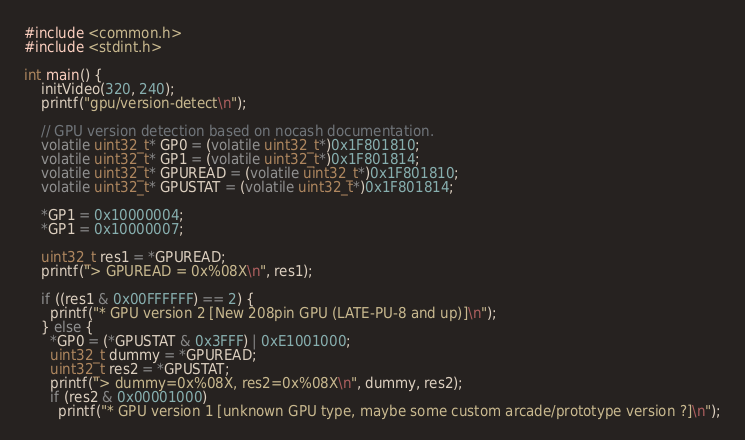<code> <loc_0><loc_0><loc_500><loc_500><_C++_>#include <common.h>
#include <stdint.h>

int main() {
    initVideo(320, 240);
    printf("gpu/version-detect\n");

    // GPU version detection based on nocash documentation.
    volatile uint32_t* GP0 = (volatile uint32_t*)0x1F801810;
    volatile uint32_t* GP1 = (volatile uint32_t*)0x1F801814;
    volatile uint32_t* GPUREAD = (volatile uint32_t*)0x1F801810;
    volatile uint32_t* GPUSTAT = (volatile uint32_t*)0x1F801814;

    *GP1 = 0x10000004;
    *GP1 = 0x10000007;

    uint32_t res1 = *GPUREAD;
    printf("> GPUREAD = 0x%08X\n", res1);

    if ((res1 & 0x00FFFFFF) == 2) {
      printf("* GPU version 2 [New 208pin GPU (LATE-PU-8 and up)]\n");
    } else {
      *GP0 = (*GPUSTAT & 0x3FFF) | 0xE1001000;
      uint32_t dummy = *GPUREAD;
      uint32_t res2 = *GPUSTAT;
      printf("> dummy=0x%08X, res2=0x%08X\n", dummy, res2);
      if (res2 & 0x00001000)
        printf("* GPU version 1 [unknown GPU type, maybe some custom arcade/prototype version ?]\n");</code> 